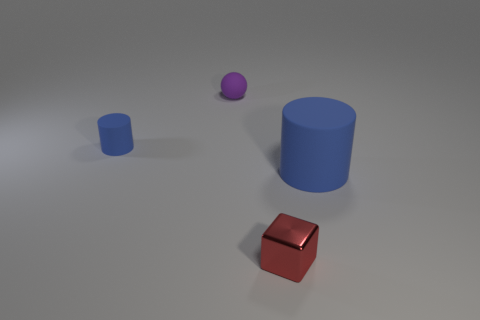Could you describe all the objects seen in the image? The image showcases four distinct objects: a large brown cube on the ground towards the front, a small blue cube positioned on the same surface but further back, behind the large cube is a tall blue cylinder, and to the left of the cylinder is a small purple sphere suspended above the ground. 